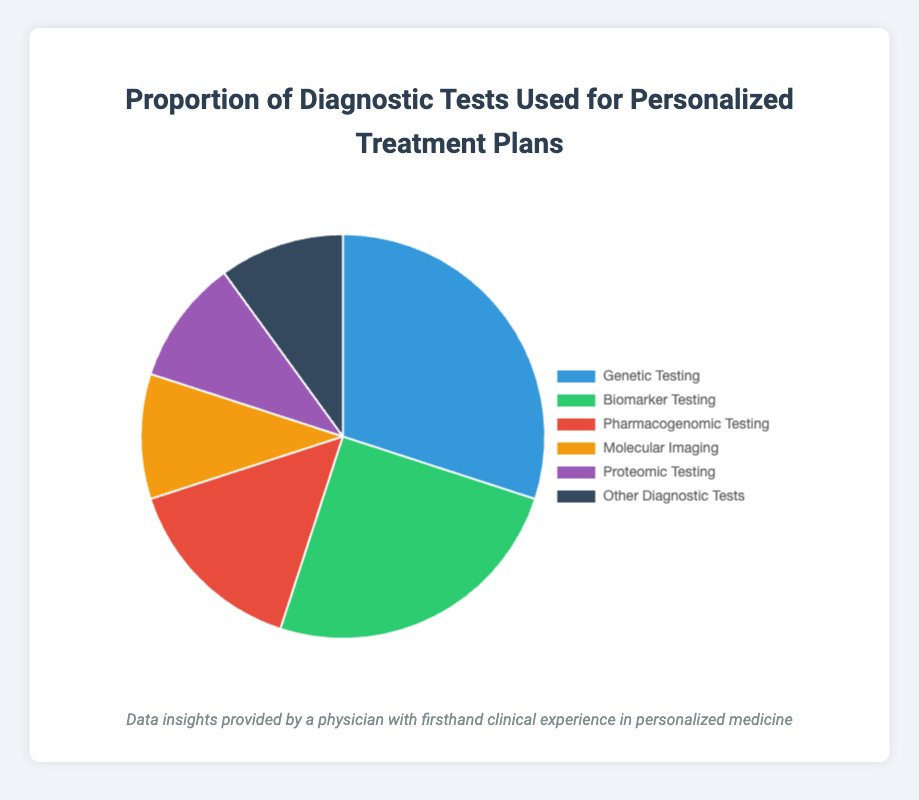What is the most commonly used diagnostic test for personalized treatment plans? From the pie chart, the segment with the largest percentage represents the most commonly used diagnostic test. The 'Genetic Testing' segment has the highest value of 30%.
Answer: Genetic Testing Which two diagnostic tests have the same proportion in the pie chart? By looking at the pie chart, the segments for 'Molecular Imaging', 'Proteomic Testing', and 'Other Diagnostic Tests' all show a value of 10%.
Answer: Molecular Imaging, Proteomic Testing, and Other Diagnostic Tests How much more prevalent is Genetic Testing compared to Pharmacogenomic Testing? Subtract the percentage of Pharmacogenomic Testing (15%) from the percentage of Genetic Testing (30%) to find the difference: 30% - 15% = 15%.
Answer: 15% What proportion of the diagnostic tests used for personalized treatment plans does Biomarker Testing constitute? Reviewing the pie chart, the segment representing Biomarker Testing displays a percentage of 25%.
Answer: 25% Compare the combined proportion of Molecular Imaging and Proteomic Testing to Biomarker Testing. Which is greater? First, add the proportions for Molecular Imaging and Proteomic Testing: 10% + 10% = 20%. Then compare 20% with the percentage for Biomarker Testing, which is 25%. Biomarker Testing's percentage is greater.
Answer: Biomarker Testing What is the total proportion of tests excluding Genetic Testing? Add the percentages for Biomarker Testing (25%), Pharmacogenomic Testing (15%), Molecular Imaging (10%), Proteomic Testing (10%), and Other Diagnostic Tests (10%): 25% + 15% + 10% + 10% + 10% = 70%.
Answer: 70% Which test type is least used according to the pie chart? Looking at the pie chart, the tests with the lowest percentage are Molecular Imaging, Proteomic Testing, and Other Diagnostic Tests, each with 10%.
Answer: Molecular Imaging, Proteomic Testing, and Other Diagnostic Tests What is the average percentage of all the diagnostic tests in the pie chart? Calculate the total sum of all percentages: 30% + 25% + 15% + 10% + 10% + 10% = 100%. Then, divide by the number of tests (6): 100% / 6 ≈ 16.67%.
Answer: 16.67% 